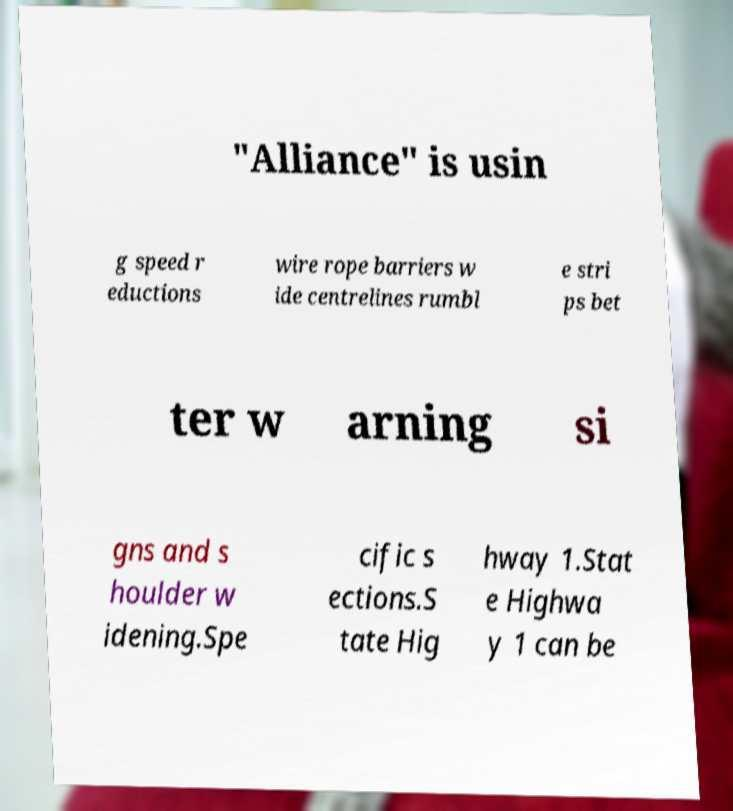Can you read and provide the text displayed in the image?This photo seems to have some interesting text. Can you extract and type it out for me? "Alliance" is usin g speed r eductions wire rope barriers w ide centrelines rumbl e stri ps bet ter w arning si gns and s houlder w idening.Spe cific s ections.S tate Hig hway 1.Stat e Highwa y 1 can be 